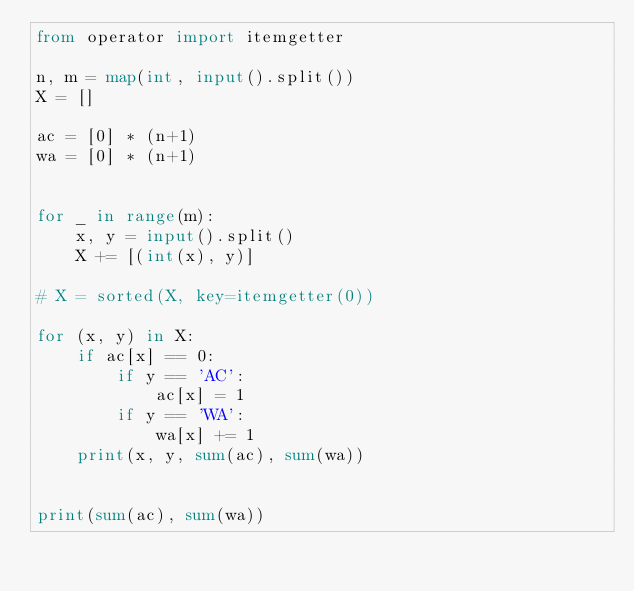<code> <loc_0><loc_0><loc_500><loc_500><_Python_>from operator import itemgetter

n, m = map(int, input().split())
X = []

ac = [0] * (n+1)
wa = [0] * (n+1)


for _ in range(m):
    x, y = input().split()
    X += [(int(x), y)]

# X = sorted(X, key=itemgetter(0))

for (x, y) in X:
    if ac[x] == 0:
        if y == 'AC':
            ac[x] = 1
        if y == 'WA':
            wa[x] += 1
    print(x, y, sum(ac), sum(wa))


print(sum(ac), sum(wa))
</code> 